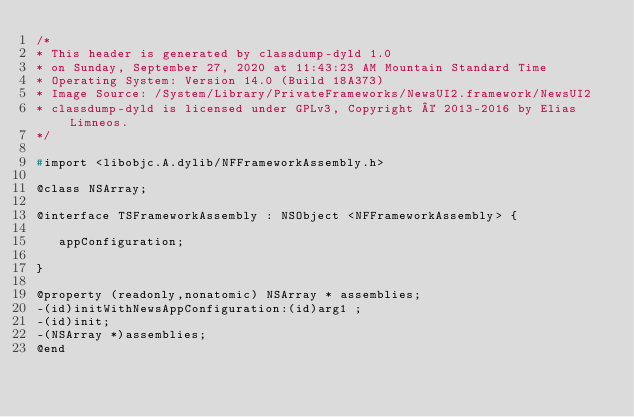<code> <loc_0><loc_0><loc_500><loc_500><_C_>/*
* This header is generated by classdump-dyld 1.0
* on Sunday, September 27, 2020 at 11:43:23 AM Mountain Standard Time
* Operating System: Version 14.0 (Build 18A373)
* Image Source: /System/Library/PrivateFrameworks/NewsUI2.framework/NewsUI2
* classdump-dyld is licensed under GPLv3, Copyright © 2013-2016 by Elias Limneos.
*/

#import <libobjc.A.dylib/NFFrameworkAssembly.h>

@class NSArray;

@interface TSFrameworkAssembly : NSObject <NFFrameworkAssembly> {

	 appConfiguration;

}

@property (readonly,nonatomic) NSArray * assemblies; 
-(id)initWithNewsAppConfiguration:(id)arg1 ;
-(id)init;
-(NSArray *)assemblies;
@end

</code> 